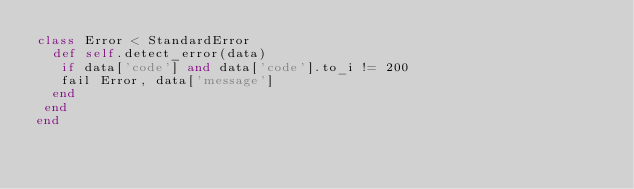Convert code to text. <code><loc_0><loc_0><loc_500><loc_500><_Ruby_>class Error < StandardError
  def self.detect_error(data)
   if data['code'] and data['code'].to_i != 200
   fail Error, data['message']
  end
 end
end
</code> 